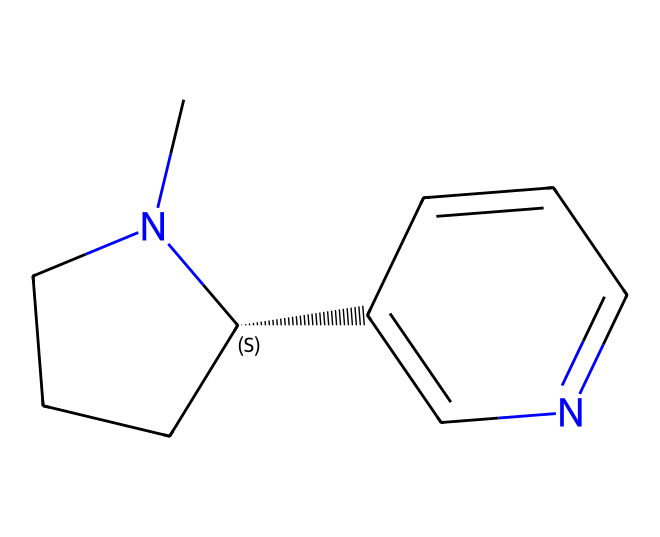how many carbon atoms are in the chemical? Analyzing the SMILES representation, each "C" denotes a carbon atom. Counting the occurrences, we find a total of 10 carbon atoms in the chemical structure.
Answer: 10 how many nitrogen atoms are there? In the SMILES, the nitrogen atoms are represented by "N". By counting, there are two "N" symbols in the structure, indicating two nitrogen atoms present.
Answer: 2 what type of chemical is nicotine classified as? Nicotine is classified as an alkaloid due to its nitrogen-containing structure and its psychoactive properties, typical of this chemical class.
Answer: alkaloid does this chemical contain any rings? The structure shows that there are two interconnected rings present in the compound, typically found in alkaloids. Each ring contains carbon and nitrogen atoms.
Answer: yes what is the total number of atoms in this molecule? To find the total number of atoms, we count the carbon (10), hydrogen (14), and nitrogen (2) atoms together: 10 + 14 + 2 = 26. Thus, the total number of atoms in nicotine is 26.
Answer: 26 which part of the structure contributes to its stimulant effects? The presence of the nitrogen atoms is crucial, as they are linked to the molecule's ability to interact with neurotransmitter receptors in the brain, influencing its stimulant effects.
Answer: nitrogen what are the implications of nicotine's basic structure on its solubility? The amine groups (indicative of nitrogen) in nicotine's structure enhance its solubility in water compared to non-polar alkaloids, due to its ability to form hydrogen bonds.
Answer: increased solubility 